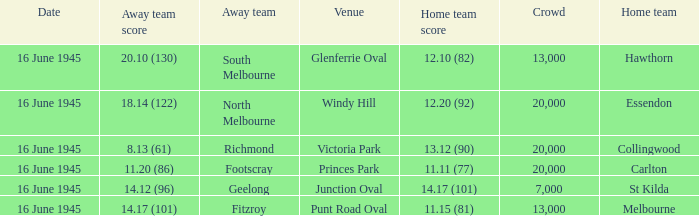What was the home team result for the squad that faced south melbourne? 12.10 (82). 